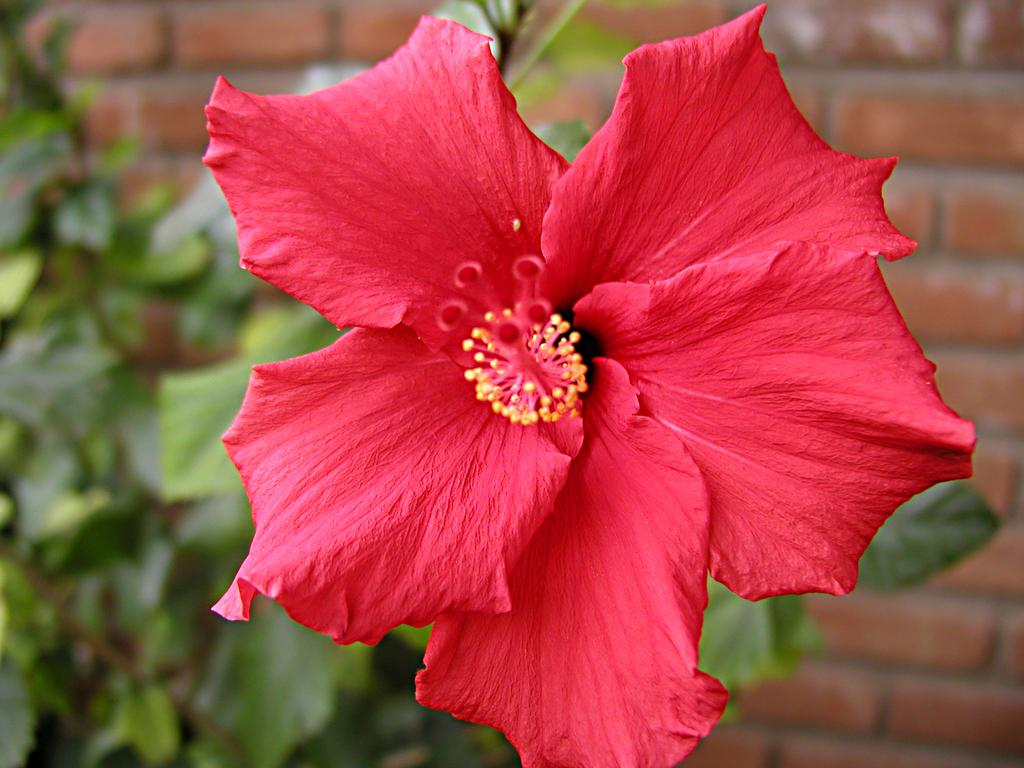What is the main subject of the image? There is a flower in the image. What can be seen in the background of the image? There is a plant and a brick wall in the background of the image. How does the flower fan itself in the image? The flower does not fan itself in the image; it is a static object. 